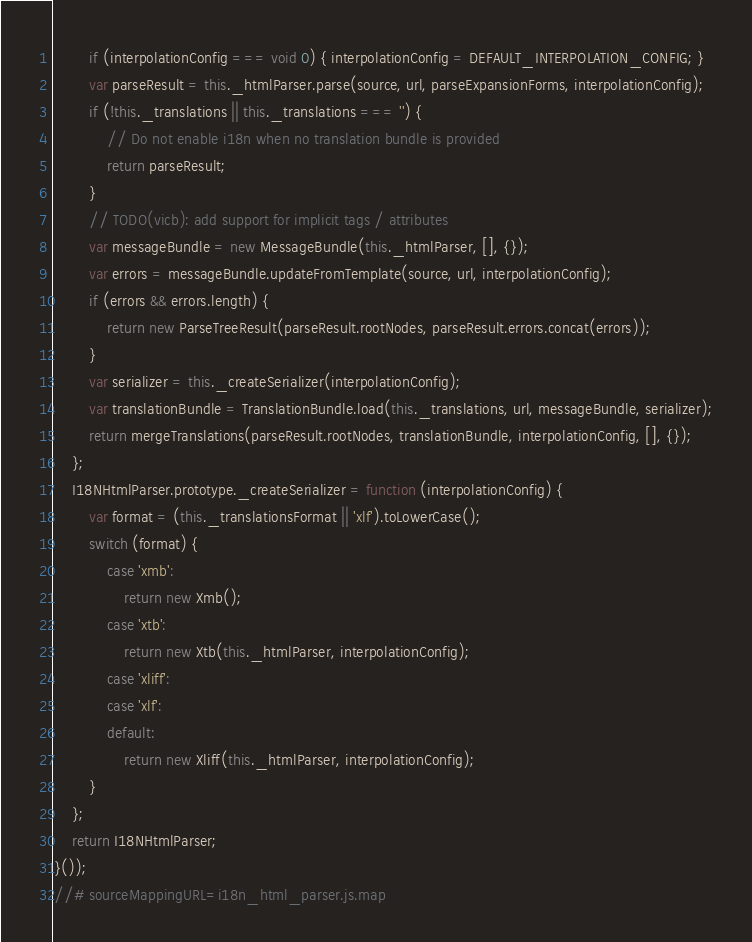Convert code to text. <code><loc_0><loc_0><loc_500><loc_500><_JavaScript_>        if (interpolationConfig === void 0) { interpolationConfig = DEFAULT_INTERPOLATION_CONFIG; }
        var parseResult = this._htmlParser.parse(source, url, parseExpansionForms, interpolationConfig);
        if (!this._translations || this._translations === '') {
            // Do not enable i18n when no translation bundle is provided
            return parseResult;
        }
        // TODO(vicb): add support for implicit tags / attributes
        var messageBundle = new MessageBundle(this._htmlParser, [], {});
        var errors = messageBundle.updateFromTemplate(source, url, interpolationConfig);
        if (errors && errors.length) {
            return new ParseTreeResult(parseResult.rootNodes, parseResult.errors.concat(errors));
        }
        var serializer = this._createSerializer(interpolationConfig);
        var translationBundle = TranslationBundle.load(this._translations, url, messageBundle, serializer);
        return mergeTranslations(parseResult.rootNodes, translationBundle, interpolationConfig, [], {});
    };
    I18NHtmlParser.prototype._createSerializer = function (interpolationConfig) {
        var format = (this._translationsFormat || 'xlf').toLowerCase();
        switch (format) {
            case 'xmb':
                return new Xmb();
            case 'xtb':
                return new Xtb(this._htmlParser, interpolationConfig);
            case 'xliff':
            case 'xlf':
            default:
                return new Xliff(this._htmlParser, interpolationConfig);
        }
    };
    return I18NHtmlParser;
}());
//# sourceMappingURL=i18n_html_parser.js.map</code> 